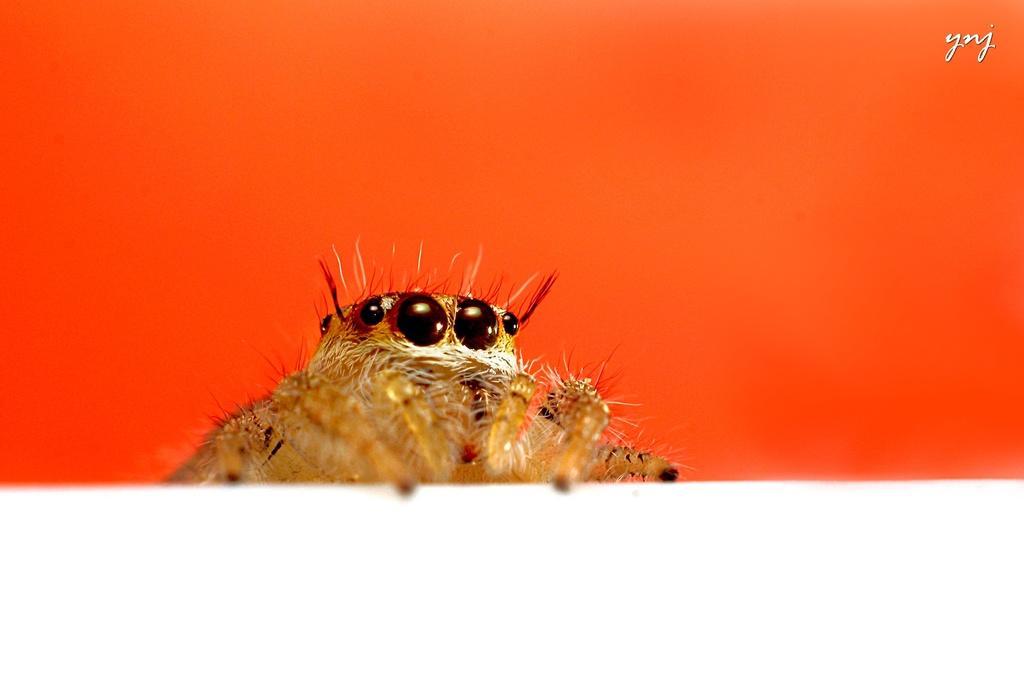Describe this image in one or two sentences. As we can see in the image there is an animal and orange color wall. 